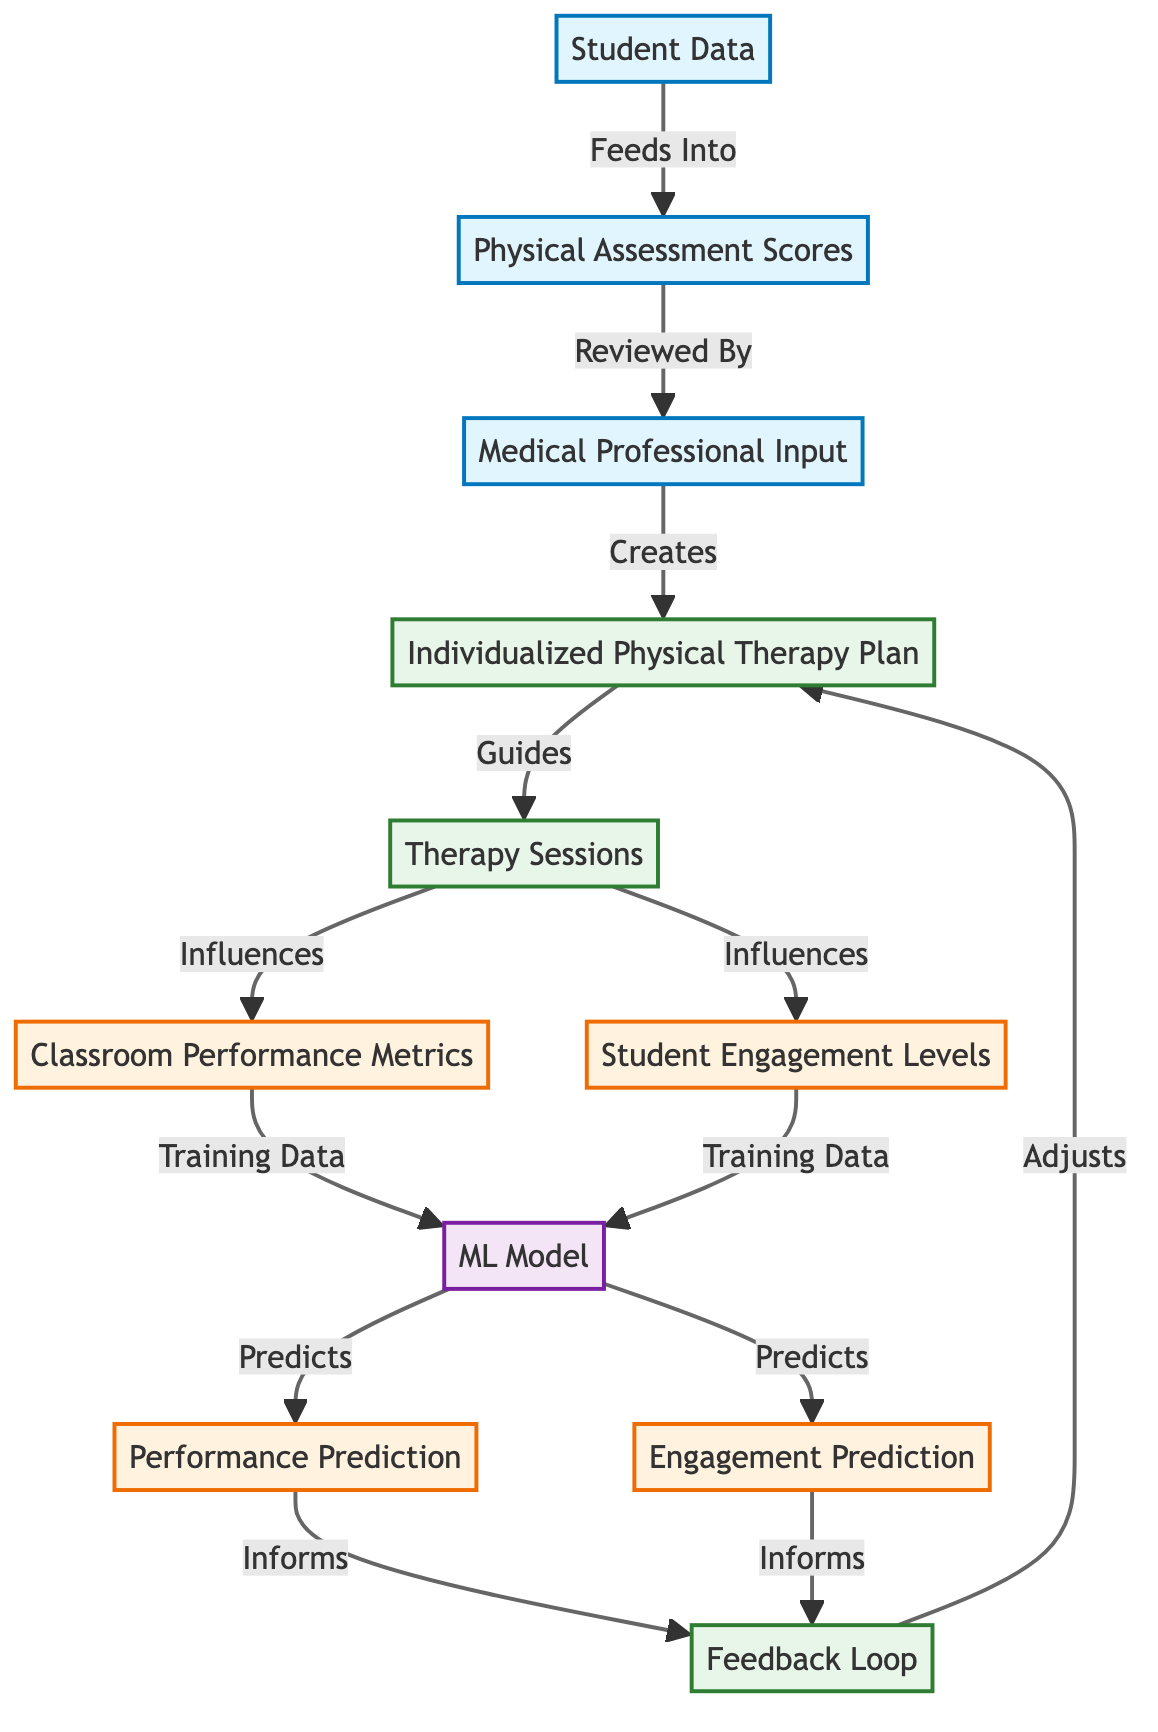What node is responsible for creating the individualized physical therapy plan? The node titled "Medical Professional Input" provides the necessary expertise and input that leads to the creation of the "Individualized Physical Therapy Plan."
Answer: Medical Professional Input How many main outputs are generated in this diagram? The diagram produces two main outputs: "Classroom Performance Metrics" and "Student Engagement Levels." Therefore, there are two outputs in total.
Answer: 2 Which node influences both classroom performance and student engagement? The node labeled "Therapy Sessions" is the process that influences both "Classroom Performance Metrics" and "Student Engagement Levels," connecting them to the therapy activities.
Answer: Therapy Sessions What does the "Machine Learning Model" predict? The "Machine Learning Model" predicts two outcomes: "Performance Prediction" and "Engagement Prediction," which are derived from the training data it receives.
Answer: Performance Prediction and Engagement Prediction What feedback mechanism is represented in the diagram? The diagram includes a "Feedback Loop" that serves as a mechanism for adjusting the "Individualized Physical Therapy Plan" based on the predictions made by the machine learning model.
Answer: Feedback Loop How does student data contribute to the evaluation process? The "Student Data" feeds into the "Physical Assessment Scores," which is critical for evaluating the initial status and guiding the further steps in the individualized plan.
Answer: Feeds Into Which processes lead to classroom performance metrics? "Therapy Sessions" directly influence "Classroom Performance Metrics" as indicated in the flow of the diagram, showing the connection between therapy and academic performance.
Answer: Therapy Sessions What are the two inputs that lead to the machine learning model? The inputs are "Classroom Performance Metrics" and "Student Engagement Levels," both of which serve as training data for the machine learning model to make predictions.
Answer: Classroom Performance Metrics and Student Engagement Levels What role does the "Individualized Physical Therapy Plan" play in the diagram? The "Individualized Physical Therapy Plan" acts as a guiding document for the "Therapy Sessions," ensuring they are tailored to the student's needs as informed by medical professionals.
Answer: Guides What outputs inform the feedback loop in this diagram? The outputs that inform the feedback loop are "Performance Prediction" and "Engagement Prediction," which provide data for adjusting the individualized plan.
Answer: Performance Prediction and Engagement Prediction 